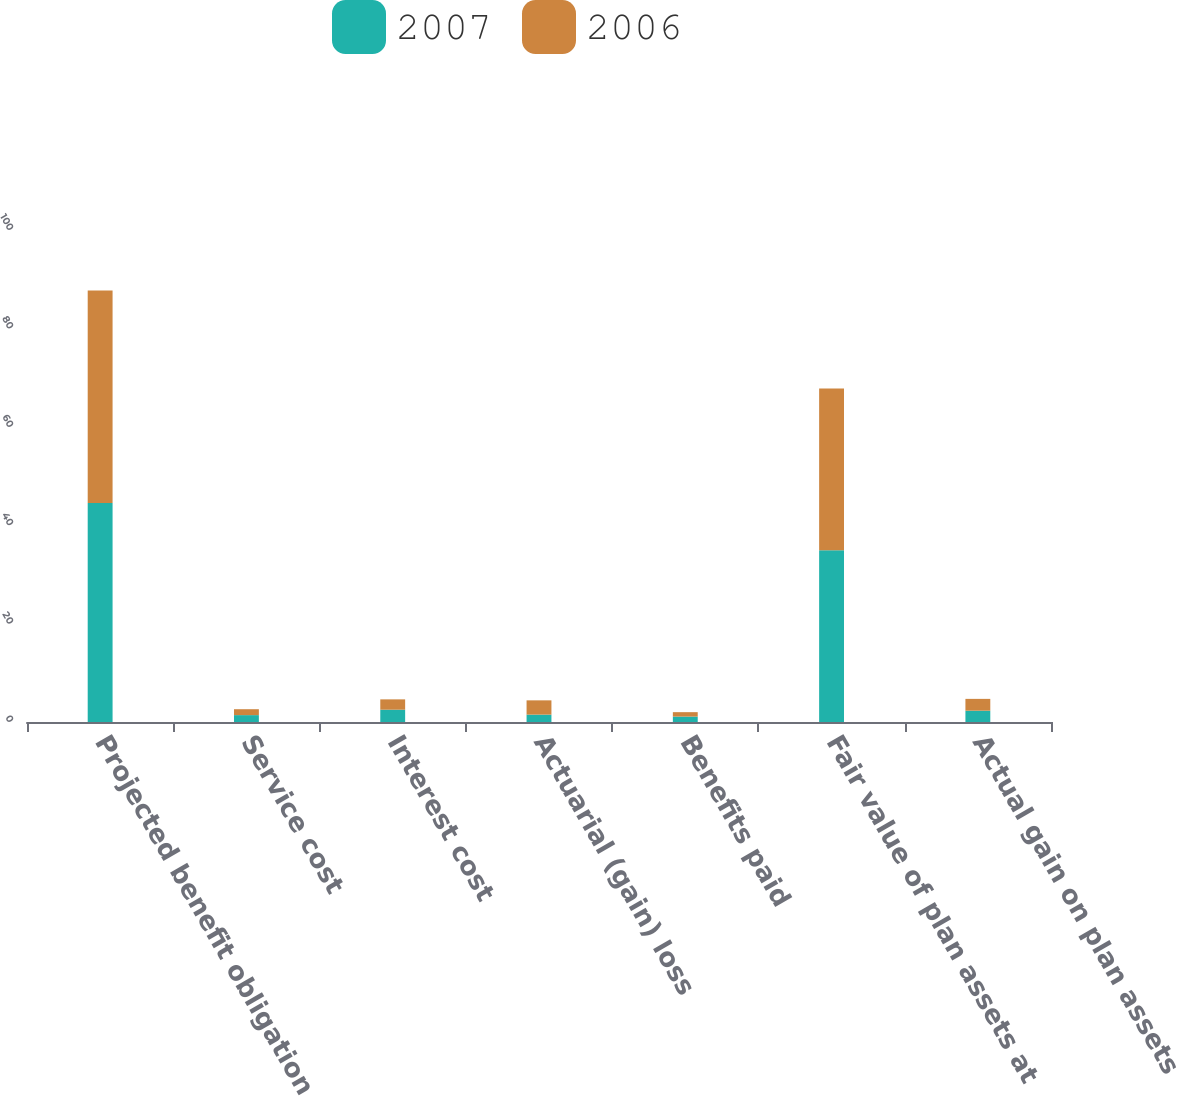Convert chart. <chart><loc_0><loc_0><loc_500><loc_500><stacked_bar_chart><ecel><fcel>Projected benefit obligation<fcel>Service cost<fcel>Interest cost<fcel>Actuarial (gain) loss<fcel>Benefits paid<fcel>Fair value of plan assets at<fcel>Actual gain on plan assets<nl><fcel>2007<fcel>44.5<fcel>1.4<fcel>2.5<fcel>1.5<fcel>1.1<fcel>34.9<fcel>2.3<nl><fcel>2006<fcel>43.2<fcel>1.2<fcel>2.1<fcel>2.9<fcel>0.9<fcel>32.9<fcel>2.4<nl></chart> 